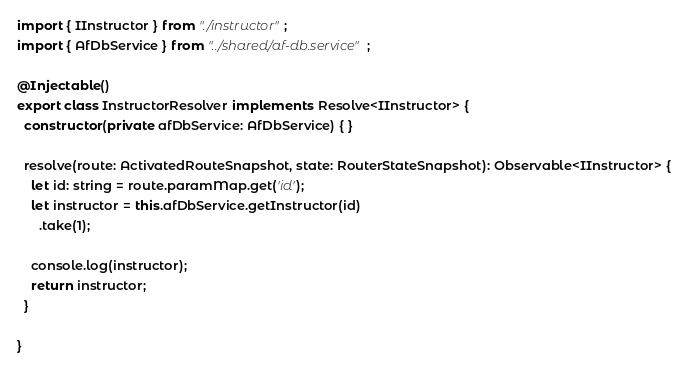Convert code to text. <code><loc_0><loc_0><loc_500><loc_500><_TypeScript_>
import { IInstructor } from "./instructor";
import { AfDbService } from "../shared/af-db.service";

@Injectable()
export class InstructorResolver implements Resolve<IInstructor> {
  constructor(private afDbService: AfDbService) { }

  resolve(route: ActivatedRouteSnapshot, state: RouterStateSnapshot): Observable<IInstructor> {
    let id: string = route.paramMap.get('id');
    let instructor = this.afDbService.getInstructor(id)
      .take(1);

    console.log(instructor);
    return instructor;
  }

}
</code> 